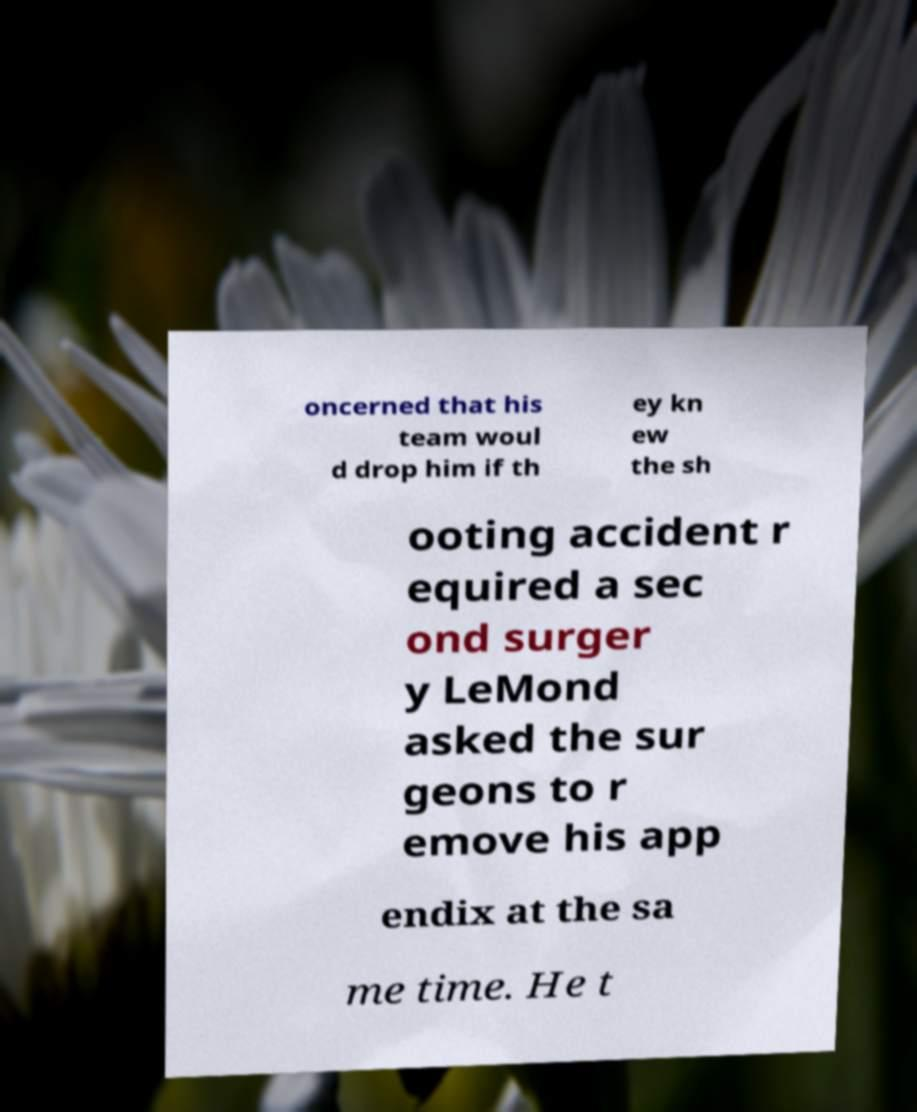Can you read and provide the text displayed in the image?This photo seems to have some interesting text. Can you extract and type it out for me? oncerned that his team woul d drop him if th ey kn ew the sh ooting accident r equired a sec ond surger y LeMond asked the sur geons to r emove his app endix at the sa me time. He t 